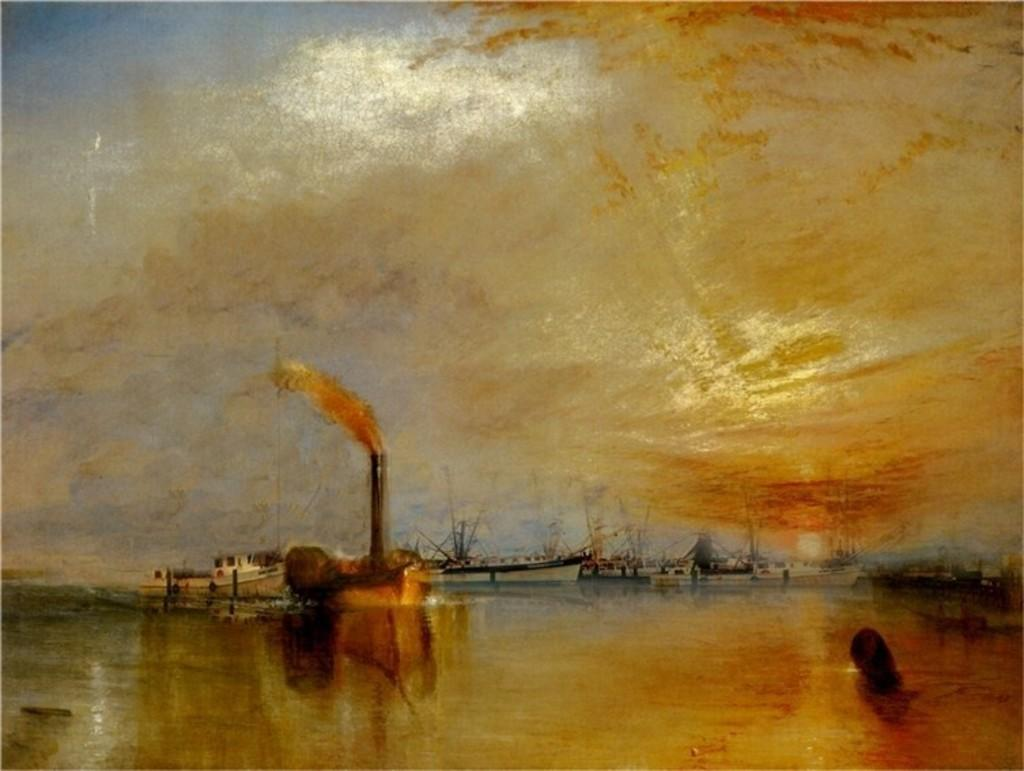What is in the foreground of the image? There is water in the foreground of the image. What is on the water in the image? There are boats on the water. What can be seen in the background of the image? The sky is visible in the image. What is the condition of the sky in the image? There are clouds in the sky. Where is the mailbox located in the image? There is no mailbox present in the image. How many stars can be seen in the image? There are no stars visible in the image; only clouds are present in the sky. 